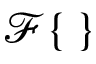Convert formula to latex. <formula><loc_0><loc_0><loc_500><loc_500>\mathcal { F } \{ \, \}</formula> 